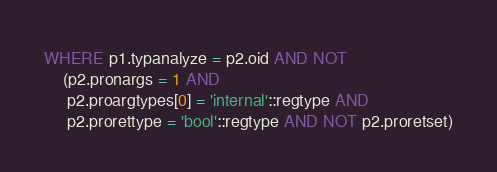<code> <loc_0><loc_0><loc_500><loc_500><_SQL_>WHERE p1.typanalyze = p2.oid AND NOT
    (p2.pronargs = 1 AND
     p2.proargtypes[0] = 'internal'::regtype AND
     p2.prorettype = 'bool'::regtype AND NOT p2.proretset)
</code> 